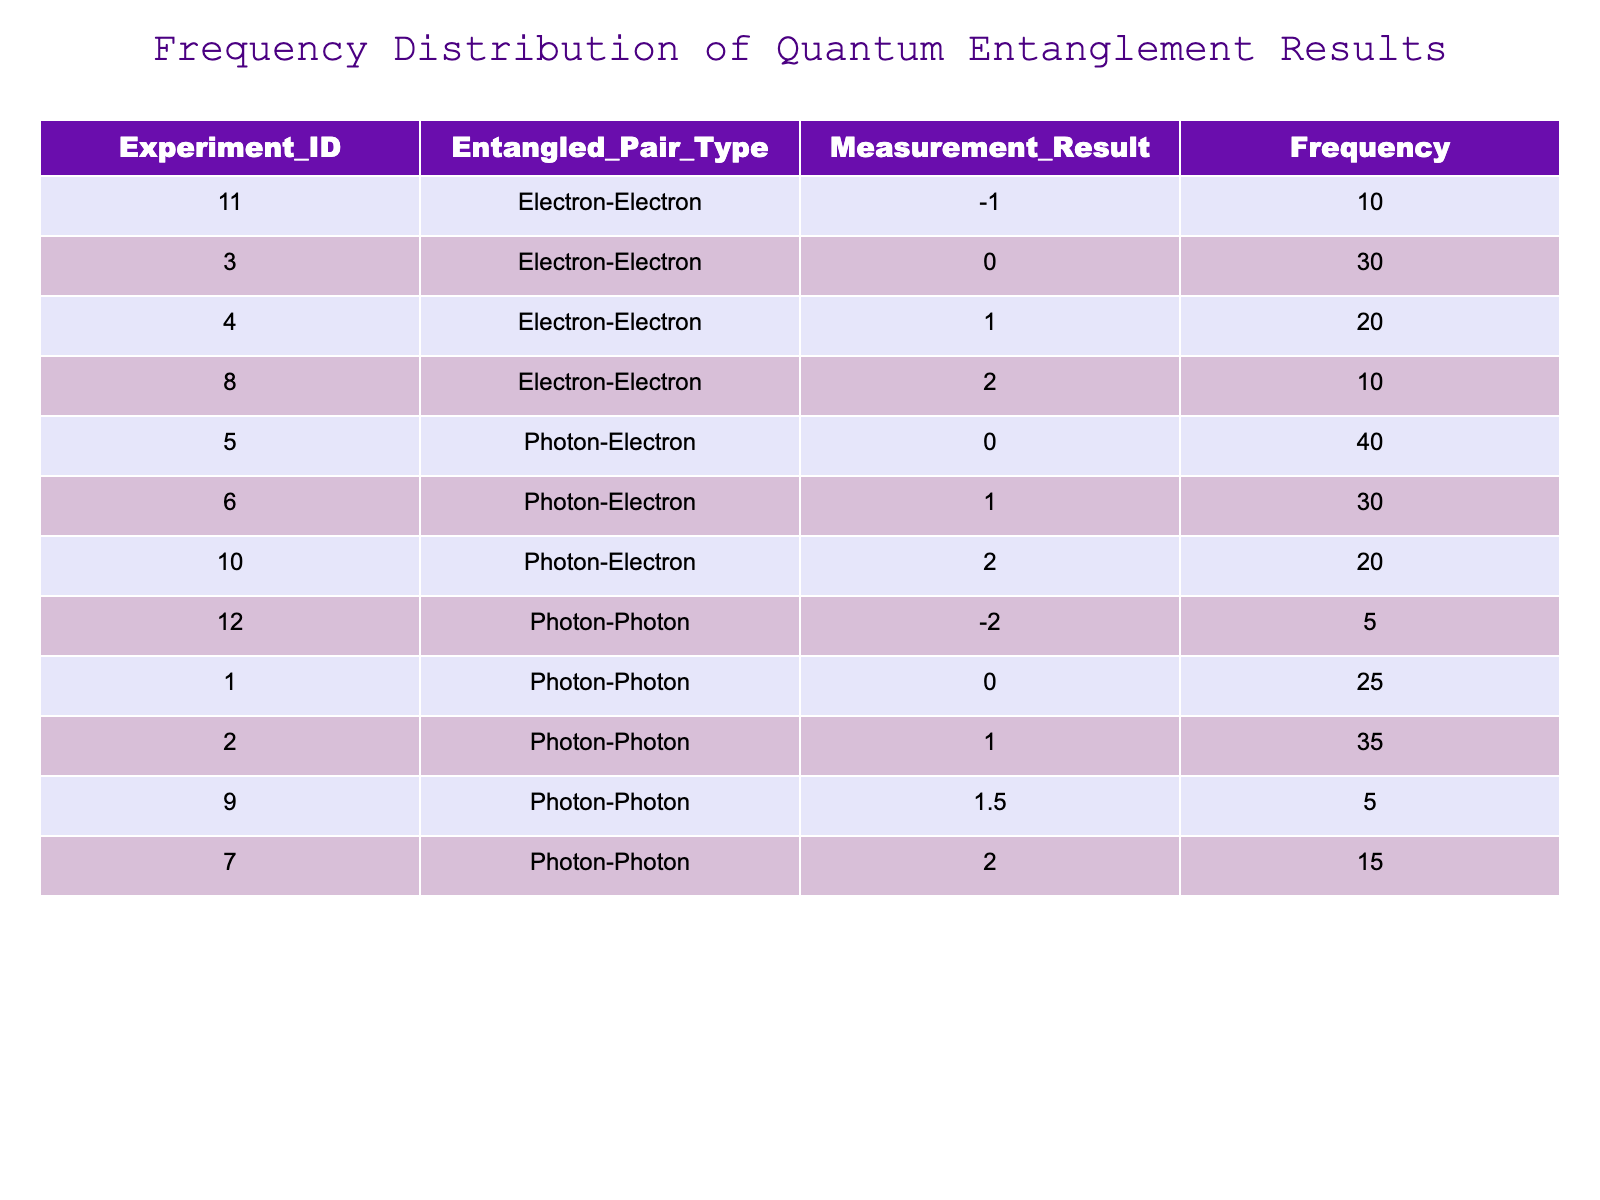What is the frequency of the measurement result "1" for Photon-Photon pairs? Referring to the table, there are two rows with "Entangled_Pair_Type" as "Photon-Photon" and "Measurement_Result" as "1". The corresponding frequency for this result is 35.
Answer: 35 How many total experiments resulted in a measurement of 0? To find this, we look for all rows where "Measurement_Result" is 0. There are three such entries with frequencies: 25 (Photon-Photon), 30 (Electron-Electron), and 40 (Photon-Electron). Adding those gives 25 + 30 + 40 = 95.
Answer: 95 Is the frequency of Electron-Electron pair type with measurement result "1" greater than the frequency of Photon-Electron pair type with measurement result "2"? From the table, the frequency for Electron-Electron with result "1" is 20, while for Photon-Electron with result "2" it is 20 as well. Therefore, they are equal, making the statement false.
Answer: No What is the total frequency of all measurements for Photon-Photon pairs? To get the total frequency for Photon-Photon, we look at the corresponding rows: 25 (result 0), 35 (result 1), 15 (result 2), and 5 (result -2). Adding these together gives: 25 + 35 + 15 + 5 = 80.
Answer: 80 What is the average measurement result for the Electron-Electron pairs? The measurement results for Electron-Electron pairs are 0 (30), 1 (20), 2 (10), and -1 (10). First, calculate the weighted sum of the results: (0*30 + 1*20 + 2*10 - 1*10) = 0 + 20 + 20 - 10 = 30. The total frequency is 30 + 20 + 10 + 10 = 70. Therefore, the average is 30 / 70 ≈ 0.429.
Answer: Approximately 0.429 